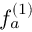Convert formula to latex. <formula><loc_0><loc_0><loc_500><loc_500>f _ { a } ^ { ( 1 ) }</formula> 